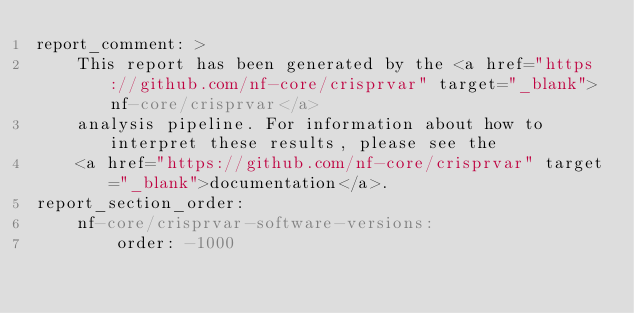Convert code to text. <code><loc_0><loc_0><loc_500><loc_500><_YAML_>report_comment: >
    This report has been generated by the <a href="https://github.com/nf-core/crisprvar" target="_blank">nf-core/crisprvar</a>
    analysis pipeline. For information about how to interpret these results, please see the
    <a href="https://github.com/nf-core/crisprvar" target="_blank">documentation</a>.
report_section_order:
    nf-core/crisprvar-software-versions:
        order: -1000
</code> 